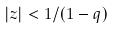Convert formula to latex. <formula><loc_0><loc_0><loc_500><loc_500>| z | < 1 / ( 1 - q )</formula> 